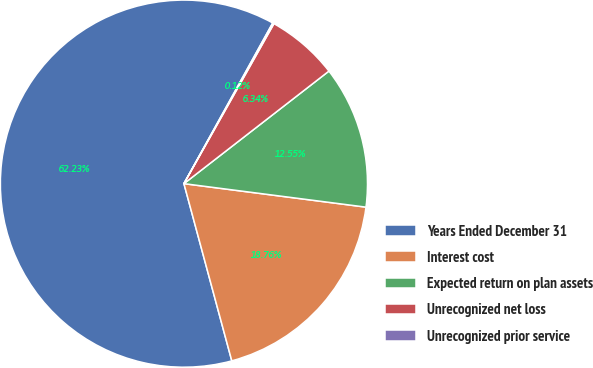Convert chart. <chart><loc_0><loc_0><loc_500><loc_500><pie_chart><fcel>Years Ended December 31<fcel>Interest cost<fcel>Expected return on plan assets<fcel>Unrecognized net loss<fcel>Unrecognized prior service<nl><fcel>62.24%<fcel>18.76%<fcel>12.55%<fcel>6.34%<fcel>0.12%<nl></chart> 